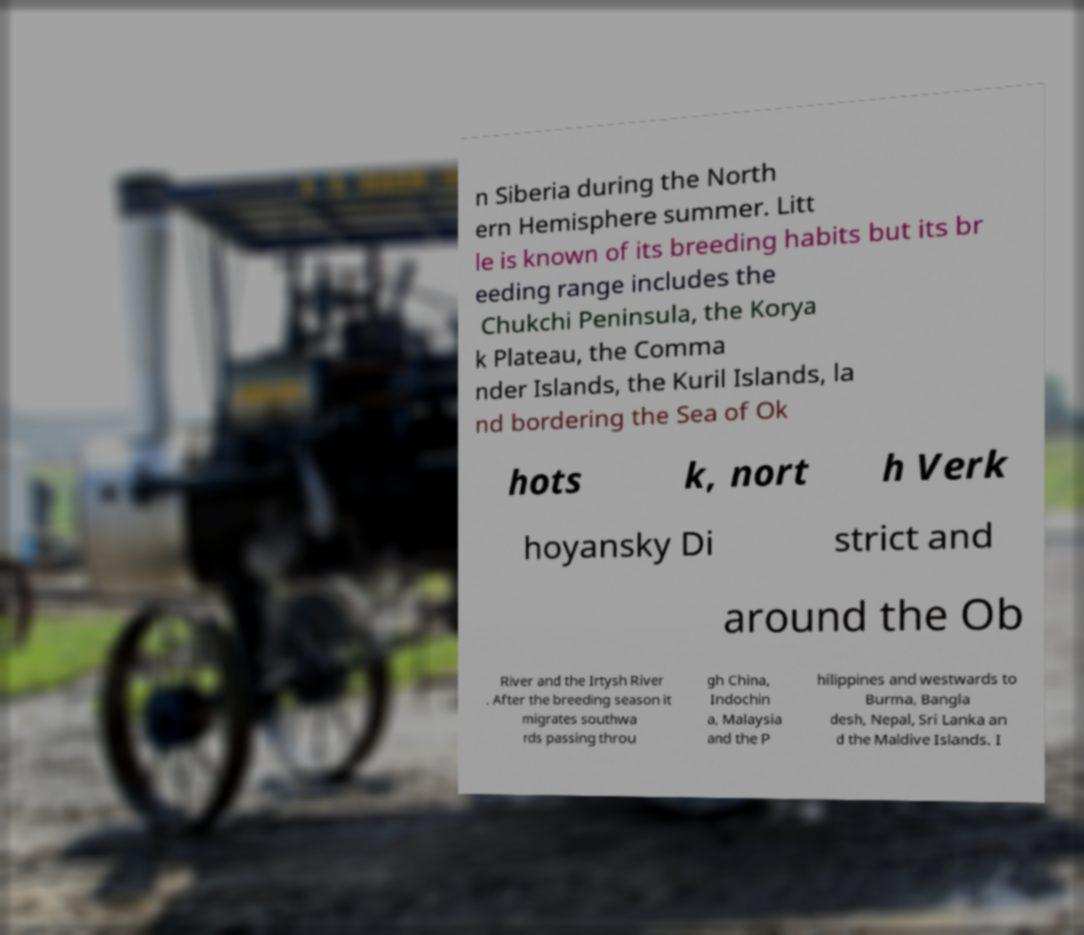There's text embedded in this image that I need extracted. Can you transcribe it verbatim? n Siberia during the North ern Hemisphere summer. Litt le is known of its breeding habits but its br eeding range includes the Chukchi Peninsula, the Korya k Plateau, the Comma nder Islands, the Kuril Islands, la nd bordering the Sea of Ok hots k, nort h Verk hoyansky Di strict and around the Ob River and the Irtysh River . After the breeding season it migrates southwa rds passing throu gh China, Indochin a, Malaysia and the P hilippines and westwards to Burma, Bangla desh, Nepal, Sri Lanka an d the Maldive Islands. I 